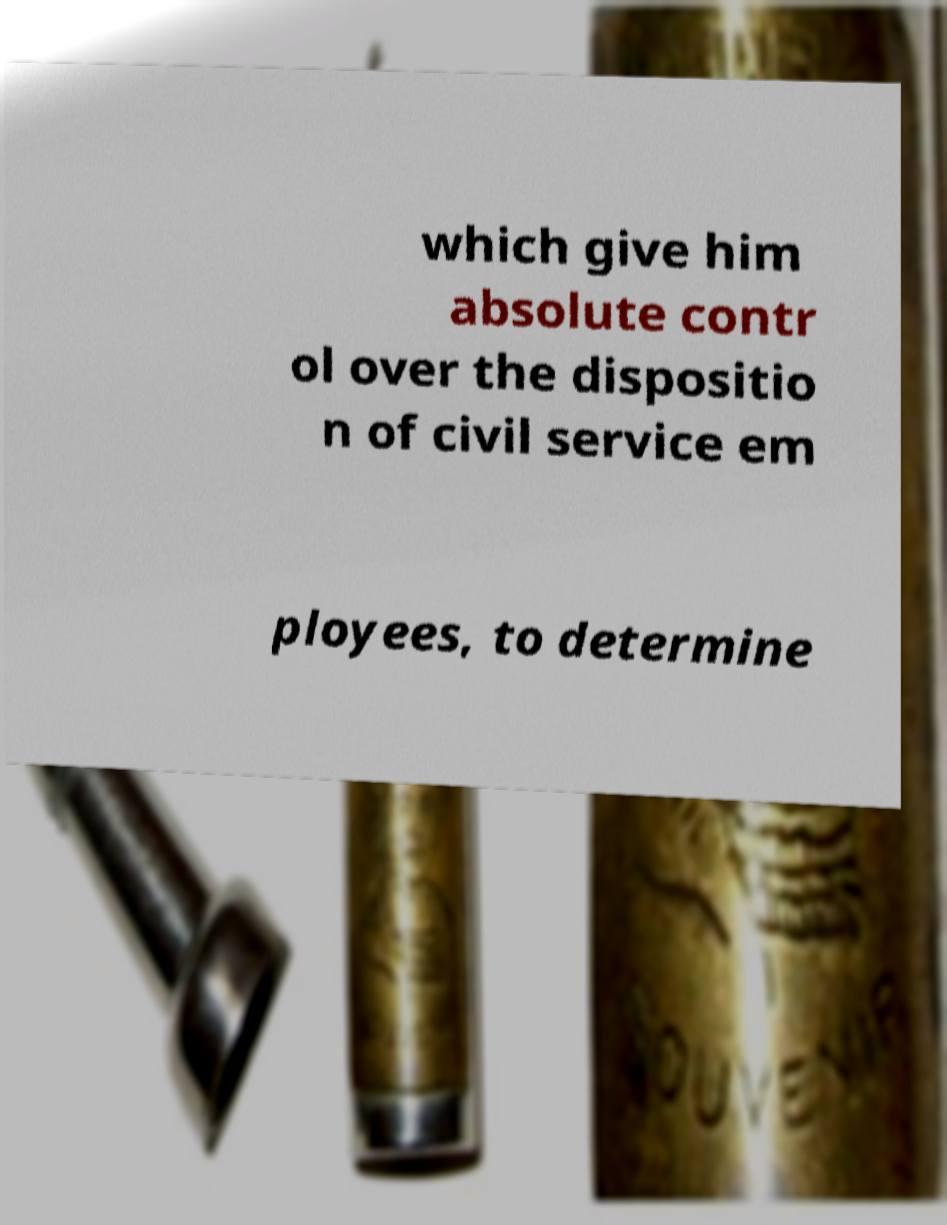Could you assist in decoding the text presented in this image and type it out clearly? which give him absolute contr ol over the dispositio n of civil service em ployees, to determine 